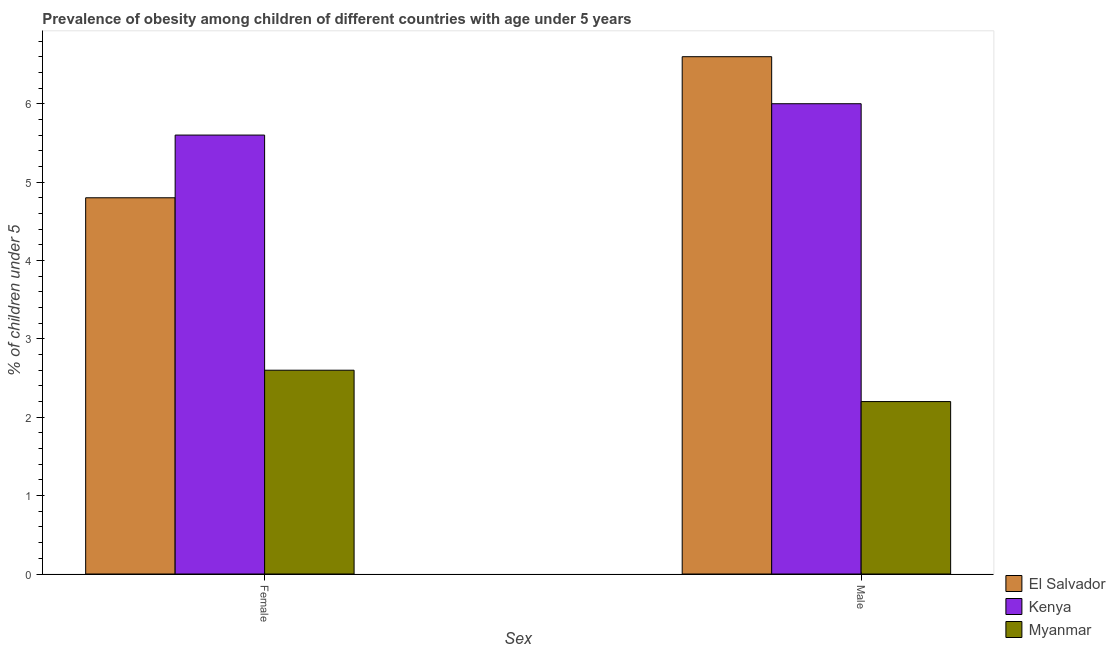Are the number of bars per tick equal to the number of legend labels?
Your answer should be compact. Yes. How many bars are there on the 2nd tick from the left?
Provide a short and direct response. 3. What is the percentage of obese male children in Myanmar?
Your answer should be very brief. 2.2. Across all countries, what is the maximum percentage of obese female children?
Offer a terse response. 5.6. Across all countries, what is the minimum percentage of obese female children?
Give a very brief answer. 2.6. In which country was the percentage of obese female children maximum?
Provide a short and direct response. Kenya. In which country was the percentage of obese male children minimum?
Your answer should be very brief. Myanmar. What is the total percentage of obese male children in the graph?
Give a very brief answer. 14.8. What is the difference between the percentage of obese female children in El Salvador and that in Kenya?
Ensure brevity in your answer.  -0.8. What is the difference between the percentage of obese male children in Myanmar and the percentage of obese female children in Kenya?
Your answer should be compact. -3.4. What is the average percentage of obese male children per country?
Make the answer very short. 4.93. What is the difference between the percentage of obese male children and percentage of obese female children in Myanmar?
Your answer should be compact. -0.4. What is the ratio of the percentage of obese female children in Kenya to that in El Salvador?
Make the answer very short. 1.17. Is the percentage of obese male children in El Salvador less than that in Kenya?
Provide a short and direct response. No. What does the 1st bar from the left in Male represents?
Ensure brevity in your answer.  El Salvador. What does the 2nd bar from the right in Female represents?
Provide a short and direct response. Kenya. How many bars are there?
Offer a terse response. 6. How many countries are there in the graph?
Your response must be concise. 3. Are the values on the major ticks of Y-axis written in scientific E-notation?
Make the answer very short. No. Does the graph contain any zero values?
Provide a succinct answer. No. How many legend labels are there?
Keep it short and to the point. 3. What is the title of the graph?
Offer a very short reply. Prevalence of obesity among children of different countries with age under 5 years. What is the label or title of the X-axis?
Offer a terse response. Sex. What is the label or title of the Y-axis?
Your answer should be compact.  % of children under 5. What is the  % of children under 5 in El Salvador in Female?
Provide a succinct answer. 4.8. What is the  % of children under 5 of Kenya in Female?
Provide a short and direct response. 5.6. What is the  % of children under 5 of Myanmar in Female?
Offer a very short reply. 2.6. What is the  % of children under 5 of El Salvador in Male?
Provide a succinct answer. 6.6. What is the  % of children under 5 of Kenya in Male?
Your answer should be compact. 6. What is the  % of children under 5 of Myanmar in Male?
Offer a terse response. 2.2. Across all Sex, what is the maximum  % of children under 5 of El Salvador?
Ensure brevity in your answer.  6.6. Across all Sex, what is the maximum  % of children under 5 of Myanmar?
Ensure brevity in your answer.  2.6. Across all Sex, what is the minimum  % of children under 5 of El Salvador?
Your response must be concise. 4.8. Across all Sex, what is the minimum  % of children under 5 in Kenya?
Your answer should be very brief. 5.6. Across all Sex, what is the minimum  % of children under 5 of Myanmar?
Offer a terse response. 2.2. What is the total  % of children under 5 of El Salvador in the graph?
Your answer should be very brief. 11.4. What is the total  % of children under 5 in Kenya in the graph?
Offer a terse response. 11.6. What is the total  % of children under 5 of Myanmar in the graph?
Give a very brief answer. 4.8. What is the difference between the  % of children under 5 of El Salvador in Female and that in Male?
Your answer should be compact. -1.8. What is the difference between the  % of children under 5 of Myanmar in Female and that in Male?
Provide a short and direct response. 0.4. What is the difference between the  % of children under 5 in El Salvador in Female and the  % of children under 5 in Myanmar in Male?
Offer a very short reply. 2.6. What is the difference between the  % of children under 5 of Kenya in Female and the  % of children under 5 of Myanmar in Male?
Give a very brief answer. 3.4. What is the average  % of children under 5 of El Salvador per Sex?
Ensure brevity in your answer.  5.7. What is the average  % of children under 5 in Myanmar per Sex?
Offer a terse response. 2.4. What is the difference between the  % of children under 5 in El Salvador and  % of children under 5 in Kenya in Female?
Your response must be concise. -0.8. What is the ratio of the  % of children under 5 of El Salvador in Female to that in Male?
Your response must be concise. 0.73. What is the ratio of the  % of children under 5 in Kenya in Female to that in Male?
Provide a succinct answer. 0.93. What is the ratio of the  % of children under 5 in Myanmar in Female to that in Male?
Your answer should be very brief. 1.18. What is the difference between the highest and the second highest  % of children under 5 of El Salvador?
Your response must be concise. 1.8. What is the difference between the highest and the second highest  % of children under 5 in Kenya?
Provide a short and direct response. 0.4. What is the difference between the highest and the lowest  % of children under 5 of El Salvador?
Your answer should be very brief. 1.8. What is the difference between the highest and the lowest  % of children under 5 in Myanmar?
Ensure brevity in your answer.  0.4. 